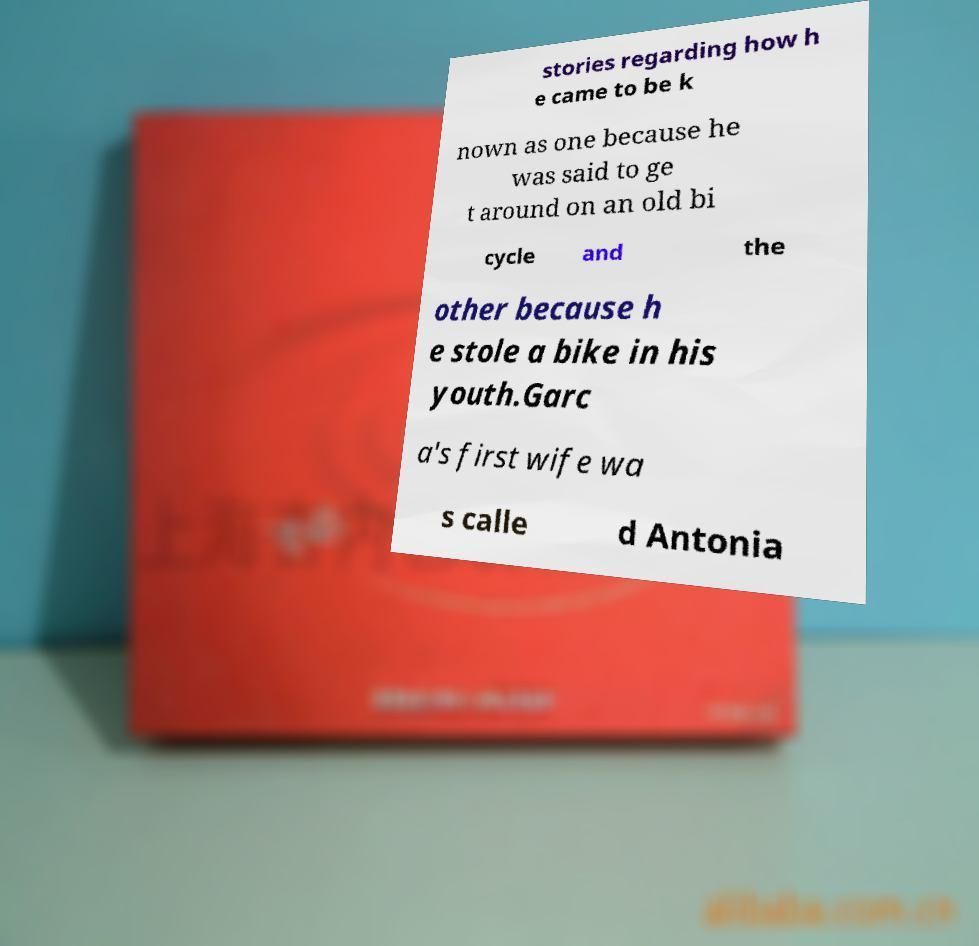Could you extract and type out the text from this image? stories regarding how h e came to be k nown as one because he was said to ge t around on an old bi cycle and the other because h e stole a bike in his youth.Garc a's first wife wa s calle d Antonia 